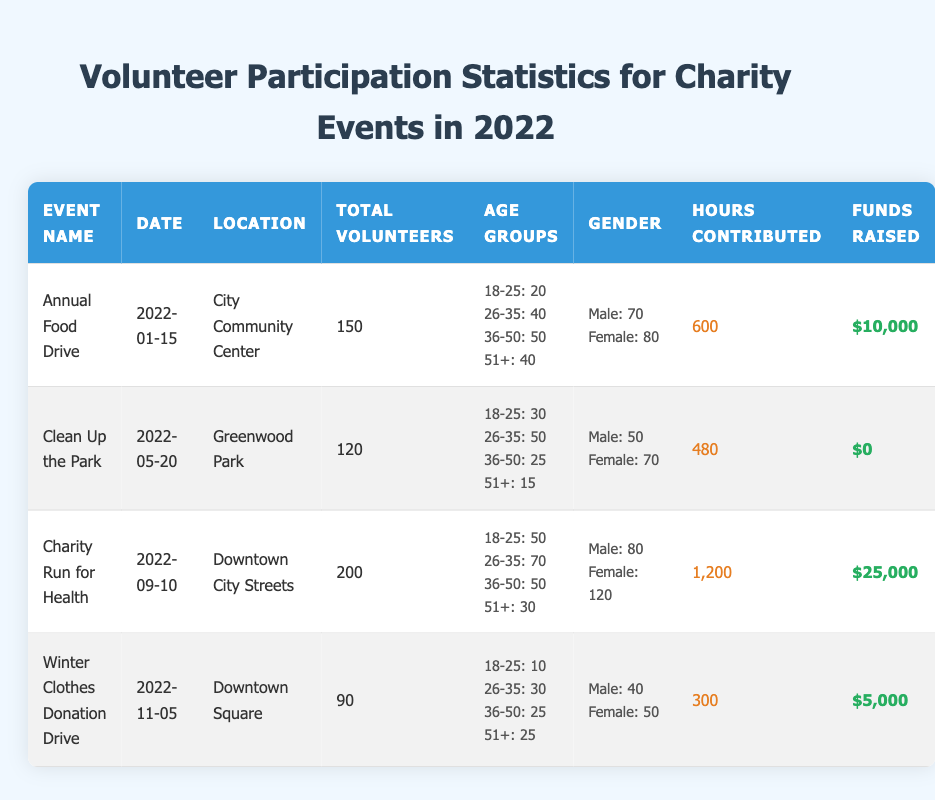What was the location of the Charity Run for Health event? The Charity Run for Health event took place on Downtown City Streets. By looking at the table in the Location column for the row corresponding to the Charity Run for Health, we can find this information directly.
Answer: Downtown City Streets How many total volunteers participated in the Annual Food Drive? The table shows that the total volunteers for the Annual Food Drive is 150. This information can be found in the Total Volunteers column in the respective row.
Answer: 150 What is the average number of hours contributed across all events? To calculate the average, first sum the contributed hours: 600 + 480 + 1200 + 300 = 2580. Then, divide by the number of events, which is 4. So, average hours = 2580/4 = 645 hours.
Answer: 645 Is it true that more female volunteers participated in the Clean Up the Park event than male volunteers? In the Clean Up the Park row, we see that there were 50 male and 70 female volunteers. Since 70 is greater than 50, the statement is true.
Answer: Yes Which event had the highest funds raised and how much was raised? By comparing the Funds Raised column for all events, we see that the Charity Run for Health event raised the most money, with a total of $25,000. This information is found in the respective row for the event.
Answer: $25,000 What was the total number of volunteers who participated in the Winter Clothes Donation Drive compared to the Clean Up the Park? The Winter Clothes Donation Drive had 90 volunteers and the Clean Up the Park had 120 volunteers. Since 120 is greater than 90, the Clean Up the Park had more volunteers by a difference of 30.
Answer: 30 more volunteers How many volunteers aged 26-35 participated in all four events combined? For the events, the contributions by age for the 26-35 group are as follows: Annual Food Drive: 40, Clean Up the Park: 50, Charity Run for Health: 70, Winter Clothes Donation Drive: 30. Adding these gives us: 40 + 50 + 70 + 30 = 190.
Answer: 190 What percentage of volunteers were male in the Charity Run for Health event? The Charity Run for Health had 200 total volunteers with 80 being male. The percentage is calculated as (80/200) * 100 = 40%. So, 40% of the volunteers were male.
Answer: 40% In how many events did the total number of volunteers exceed 100? By reviewing the Total Volunteers column, we see three events exceeded 100 volunteers: Charity Run for Health (200), Annual Food Drive (150), and Clean Up the Park (120). Thus, the total is 3 events.
Answer: 3 